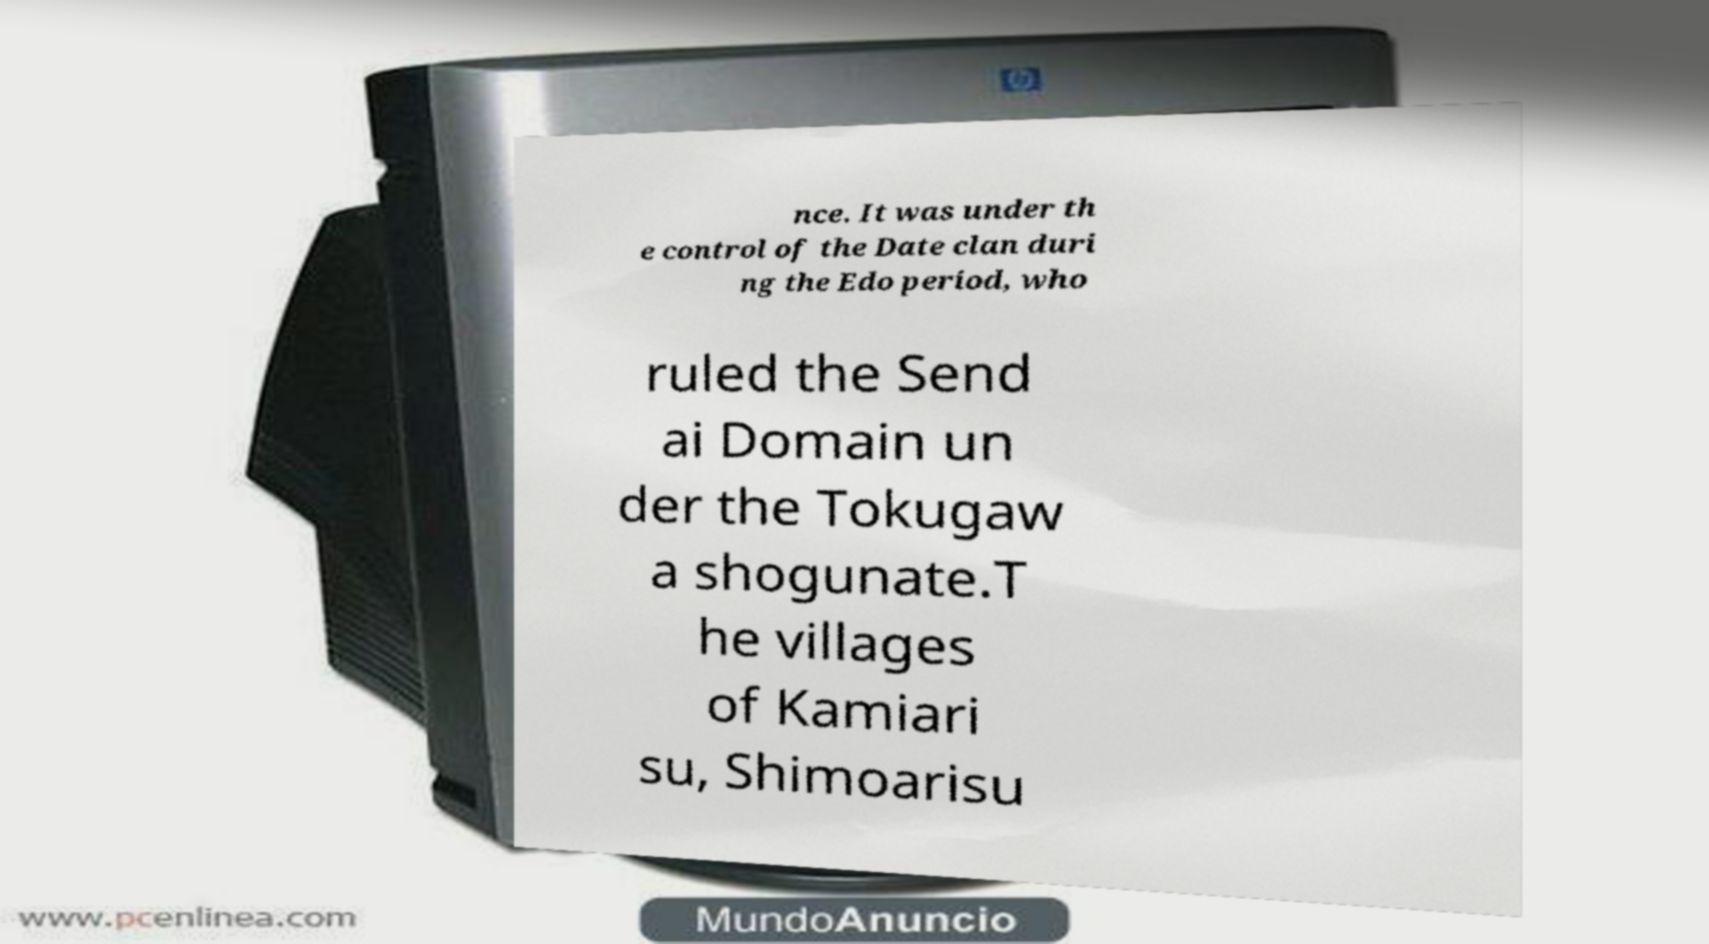Can you accurately transcribe the text from the provided image for me? nce. It was under th e control of the Date clan duri ng the Edo period, who ruled the Send ai Domain un der the Tokugaw a shogunate.T he villages of Kamiari su, Shimoarisu 